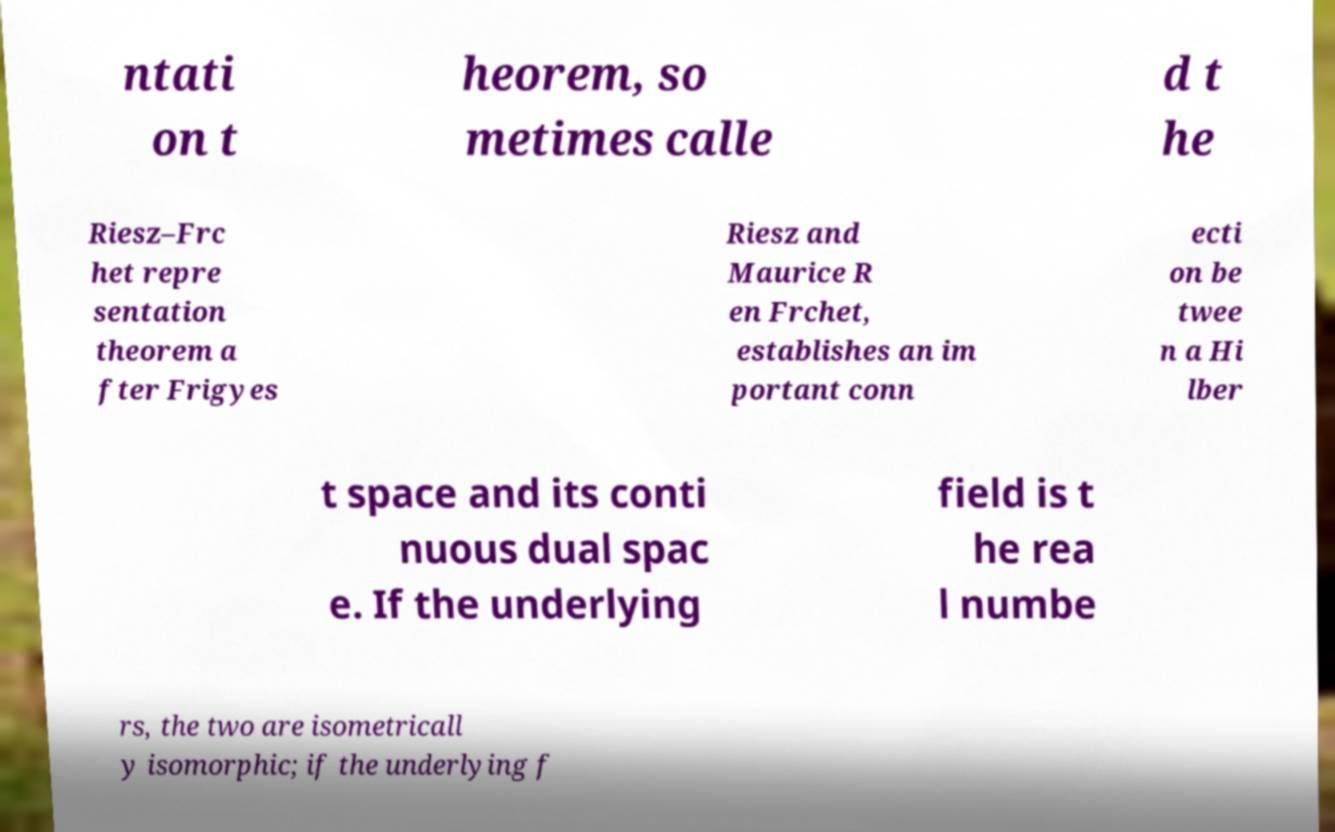For documentation purposes, I need the text within this image transcribed. Could you provide that? ntati on t heorem, so metimes calle d t he Riesz–Frc het repre sentation theorem a fter Frigyes Riesz and Maurice R en Frchet, establishes an im portant conn ecti on be twee n a Hi lber t space and its conti nuous dual spac e. If the underlying field is t he rea l numbe rs, the two are isometricall y isomorphic; if the underlying f 